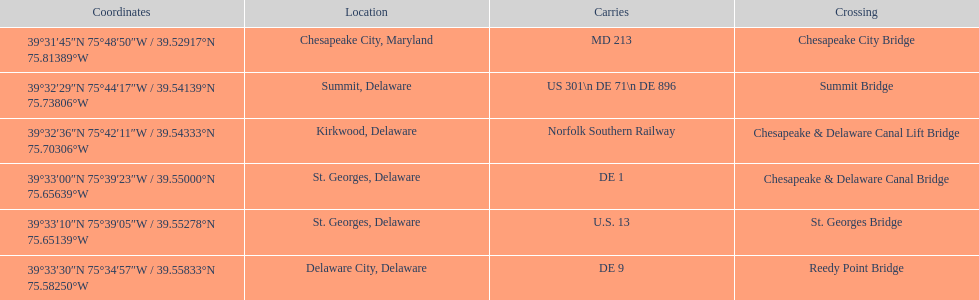Which bridge has their location in summit, delaware? Summit Bridge. 